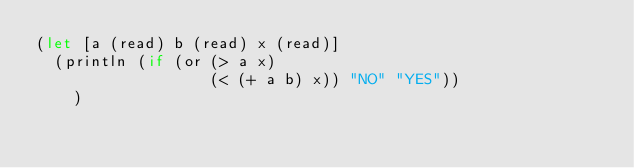<code> <loc_0><loc_0><loc_500><loc_500><_Clojure_>(let [a (read) b (read) x (read)]
  (println (if (or (> a x)
                   (< (+ a b) x)) "NO" "YES")) 
  	)</code> 